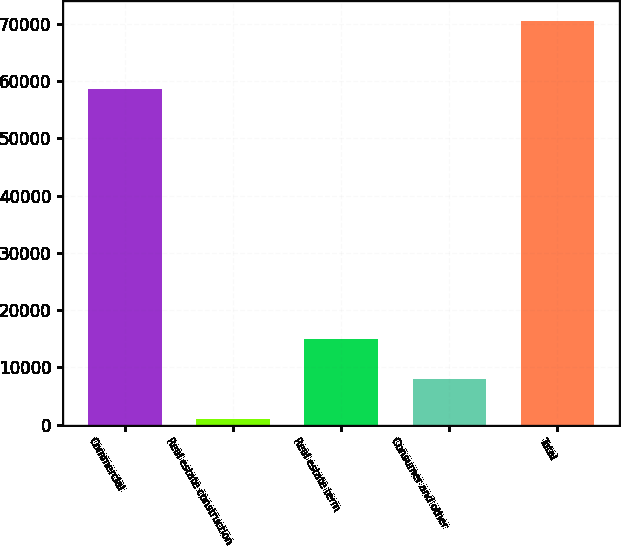<chart> <loc_0><loc_0><loc_500><loc_500><bar_chart><fcel>Commercial<fcel>Real estate construction<fcel>Real estate term<fcel>Consumer and other<fcel>Total<nl><fcel>58702<fcel>1016<fcel>14912.8<fcel>7964.4<fcel>70500<nl></chart> 